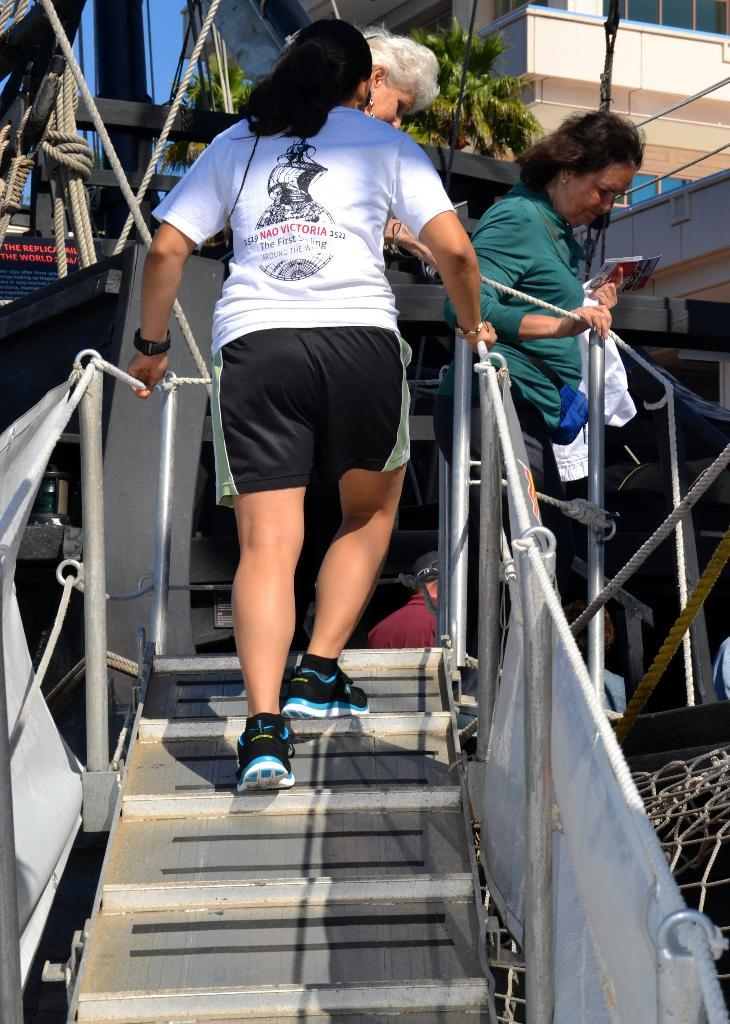Who is the main subject in the image? There is a man in the center of the image. What can be seen at the top side of the image? There are other people and buildings at the top side of the image. What type of disease is being treated by the expert in the image? There is no expert or disease present in the image. 